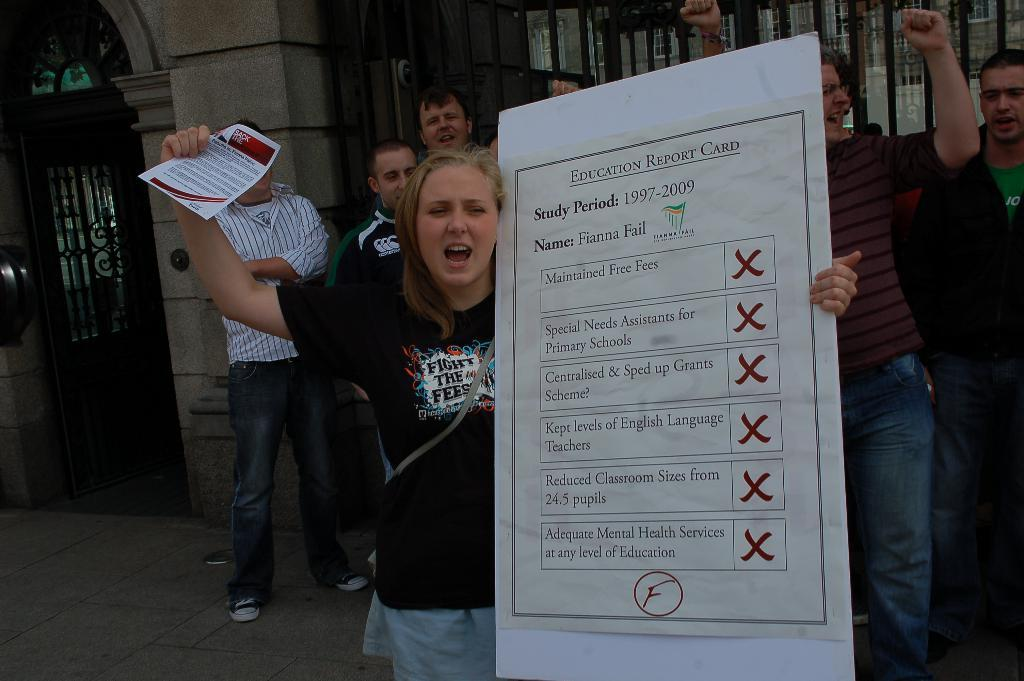Who is the main subject in the image? There is a lady in the image. What is the lady holding in the image? The lady is holding a board. What can be seen on the board? There is text on the board. What is visible in the background of the image? There are people standing and a building in the background of the image. What type of berry is the kitten eating in the image? There is no kitten or berry present in the image. Is the lady standing on a rail in the image? There is no rail mentioned or visible in the image. 